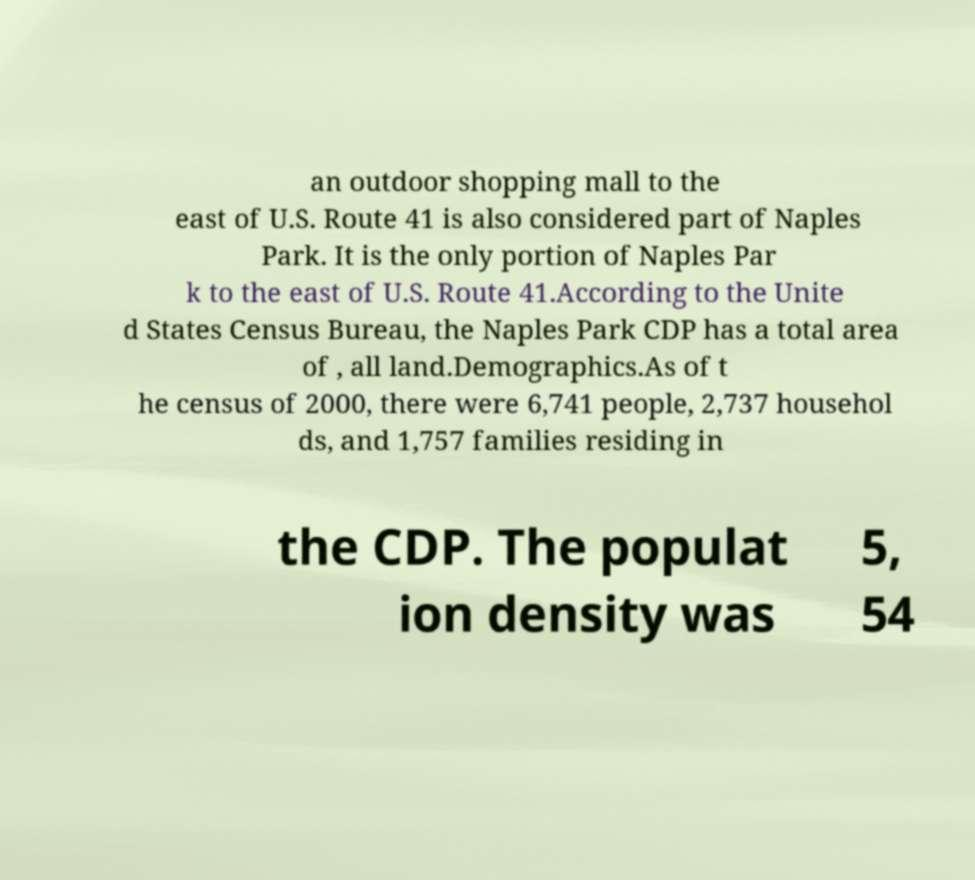Please identify and transcribe the text found in this image. an outdoor shopping mall to the east of U.S. Route 41 is also considered part of Naples Park. It is the only portion of Naples Par k to the east of U.S. Route 41.According to the Unite d States Census Bureau, the Naples Park CDP has a total area of , all land.Demographics.As of t he census of 2000, there were 6,741 people, 2,737 househol ds, and 1,757 families residing in the CDP. The populat ion density was 5, 54 